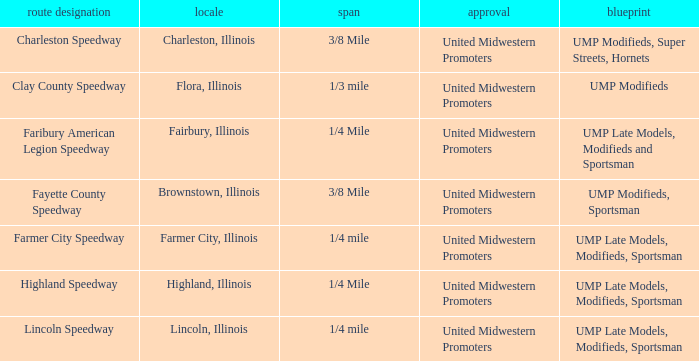Who sanctioned the event at fayette county speedway? United Midwestern Promoters. 